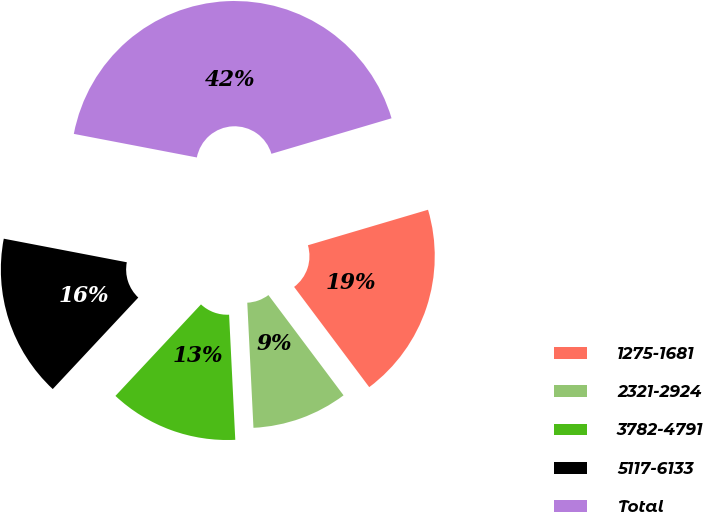Convert chart to OTSL. <chart><loc_0><loc_0><loc_500><loc_500><pie_chart><fcel>1275-1681<fcel>2321-2924<fcel>3782-4791<fcel>5117-6133<fcel>Total<nl><fcel>19.34%<fcel>9.45%<fcel>12.75%<fcel>16.05%<fcel>42.41%<nl></chart> 